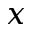<formula> <loc_0><loc_0><loc_500><loc_500>x</formula> 